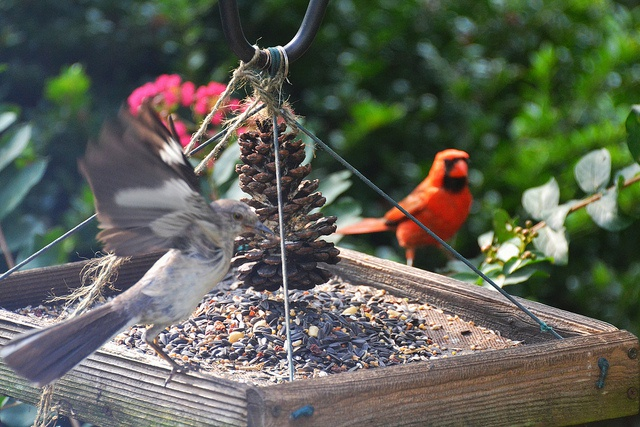Describe the objects in this image and their specific colors. I can see bird in purple, gray, darkgray, and lightgray tones and bird in purple, brown, maroon, black, and salmon tones in this image. 